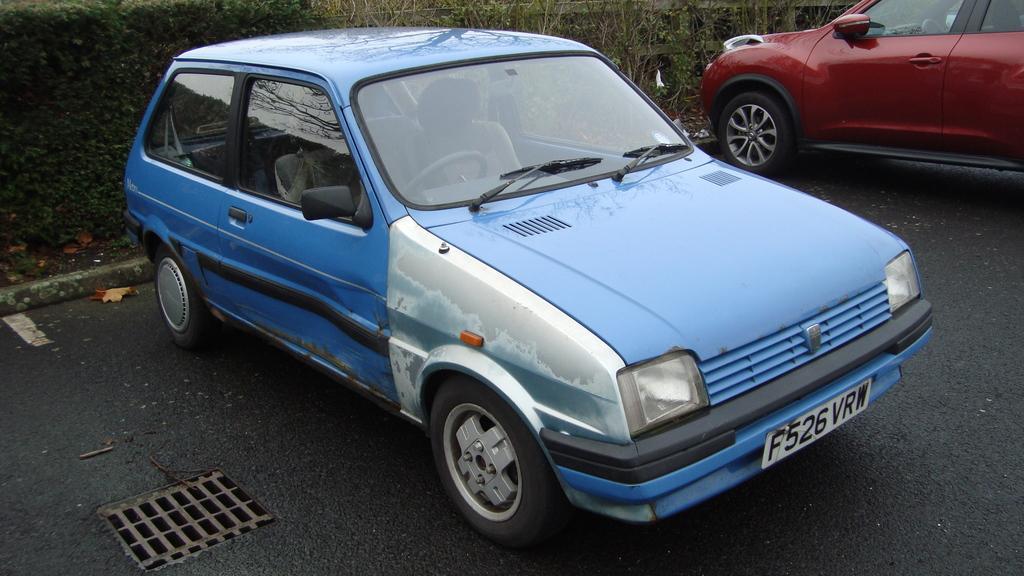How would you summarize this image in a sentence or two? In this image I can see a red and blue color car on the road. In the background I can see plants and grass. This image is taken on the road. 